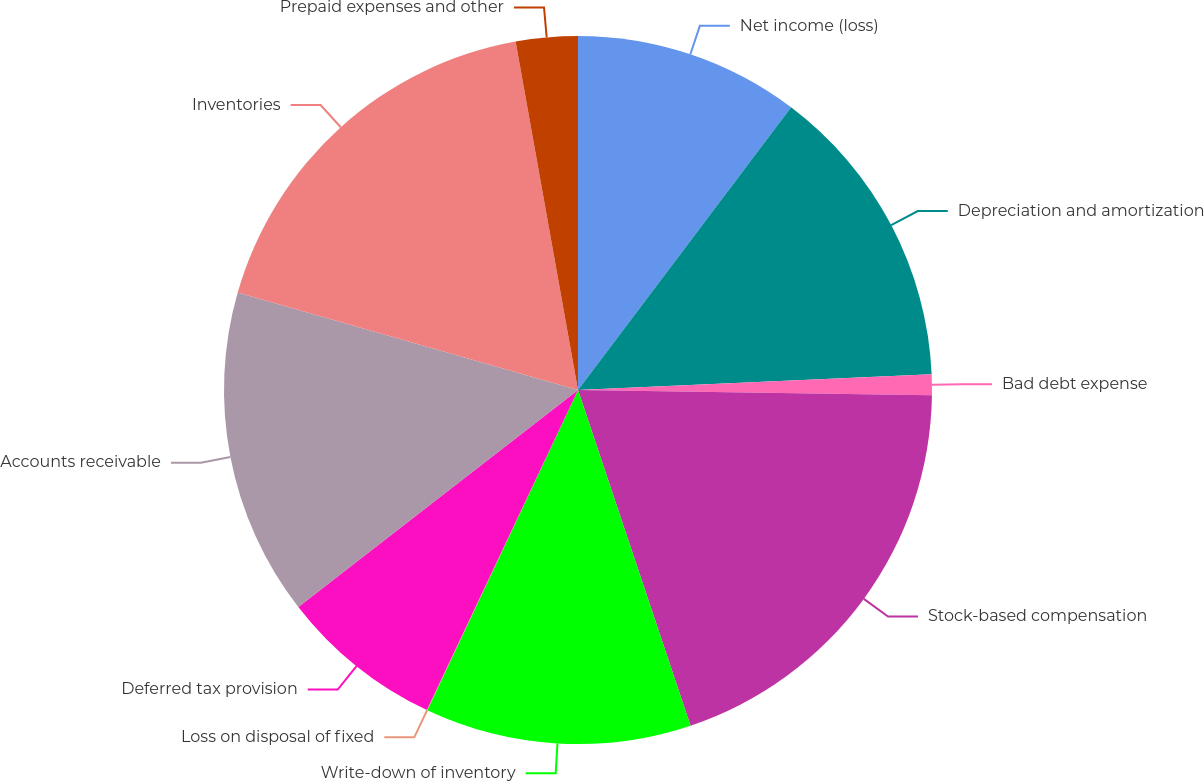<chart> <loc_0><loc_0><loc_500><loc_500><pie_chart><fcel>Net income (loss)<fcel>Depreciation and amortization<fcel>Bad debt expense<fcel>Stock-based compensation<fcel>Write-down of inventory<fcel>Loss on disposal of fixed<fcel>Deferred tax provision<fcel>Accounts receivable<fcel>Inventories<fcel>Prepaid expenses and other<nl><fcel>10.28%<fcel>14.01%<fcel>0.95%<fcel>19.61%<fcel>12.15%<fcel>0.02%<fcel>7.48%<fcel>14.94%<fcel>17.74%<fcel>2.82%<nl></chart> 